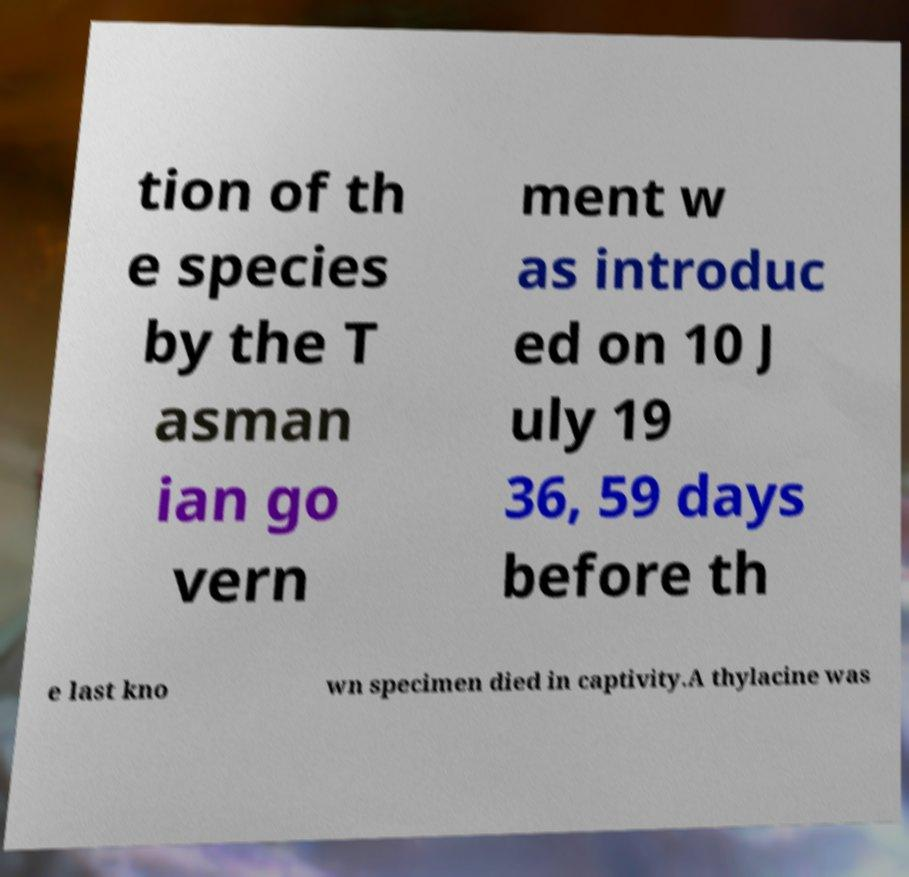Can you accurately transcribe the text from the provided image for me? tion of th e species by the T asman ian go vern ment w as introduc ed on 10 J uly 19 36, 59 days before th e last kno wn specimen died in captivity.A thylacine was 